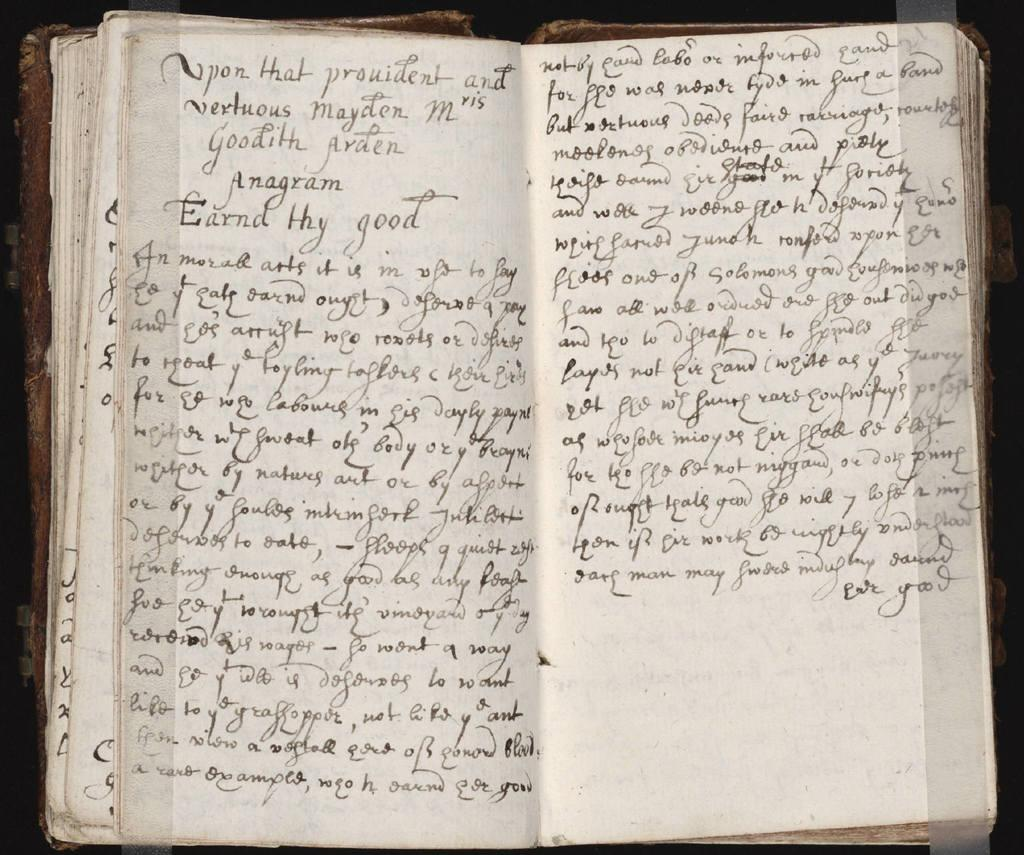<image>
Present a compact description of the photo's key features. A book open to two pages of handwritten words that starts with, "Upon that Provident..." 